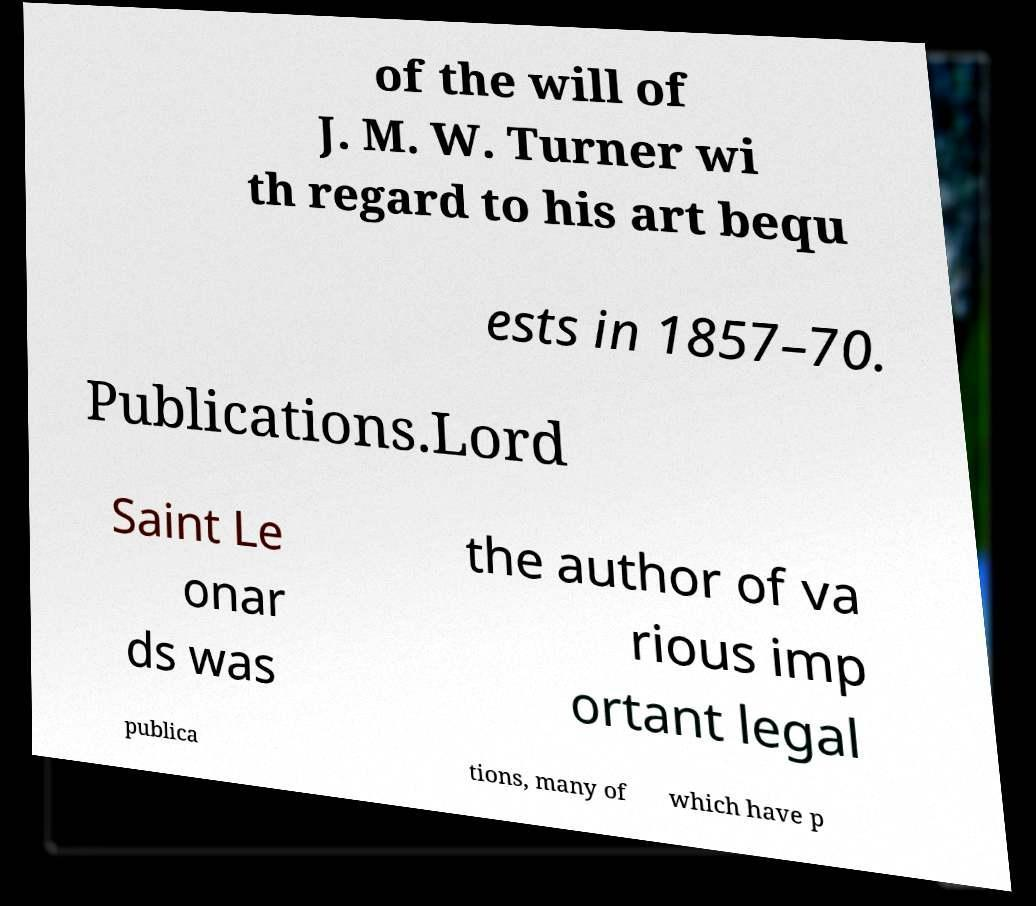What messages or text are displayed in this image? I need them in a readable, typed format. of the will of J. M. W. Turner wi th regard to his art bequ ests in 1857–70. Publications.Lord Saint Le onar ds was the author of va rious imp ortant legal publica tions, many of which have p 